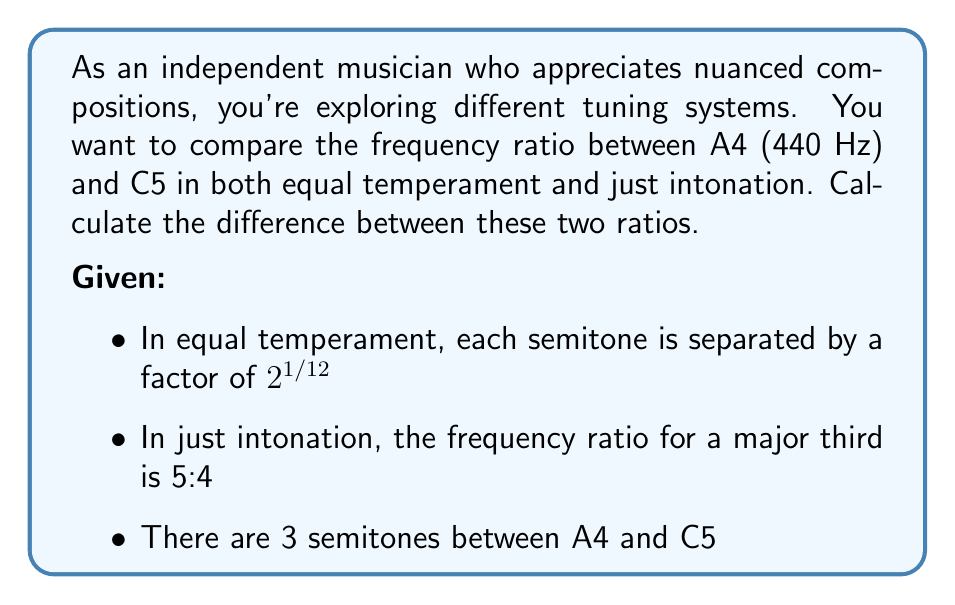Could you help me with this problem? Let's approach this step-by-step:

1. Equal Temperament (ET):
   - The frequency ratio for 3 semitones in ET is $(2^{1/12})^3 = 2^{1/4}$
   - Frequency of C5 in ET = 440 Hz * $2^{1/4}$
   - Ratio in ET = $2^{1/4} \approx 1.189207115$

2. Just Intonation (JI):
   - The frequency ratio for a major third in JI is 5:4 = 1.25
   - Ratio in JI = 1.25

3. Calculate the difference:
   Difference = JI ratio - ET ratio
               = 1.25 - $2^{1/4}$
               = 1.25 - 1.189207115
               ≈ 0.060792885

This subtle difference in ratios contributes to the distinct character of each tuning system, which a discerning musician might appreciate in nuanced compositions.
Answer: The difference between the frequency ratios of A4 to C5 in just intonation and equal temperament is approximately 0.060792885. 